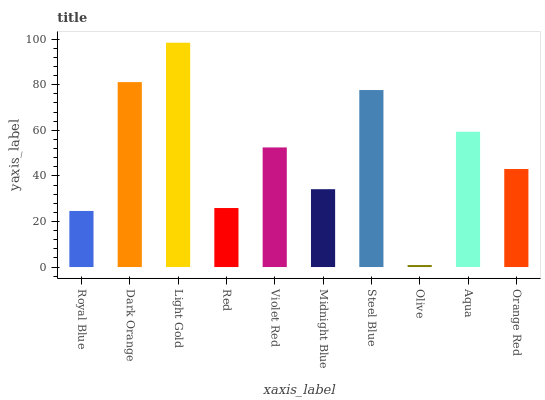Is Olive the minimum?
Answer yes or no. Yes. Is Light Gold the maximum?
Answer yes or no. Yes. Is Dark Orange the minimum?
Answer yes or no. No. Is Dark Orange the maximum?
Answer yes or no. No. Is Dark Orange greater than Royal Blue?
Answer yes or no. Yes. Is Royal Blue less than Dark Orange?
Answer yes or no. Yes. Is Royal Blue greater than Dark Orange?
Answer yes or no. No. Is Dark Orange less than Royal Blue?
Answer yes or no. No. Is Violet Red the high median?
Answer yes or no. Yes. Is Orange Red the low median?
Answer yes or no. Yes. Is Red the high median?
Answer yes or no. No. Is Steel Blue the low median?
Answer yes or no. No. 